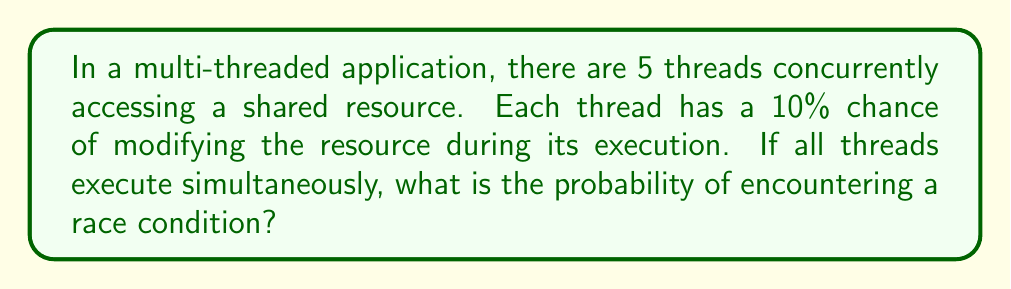Can you solve this math problem? Let's approach this step-by-step:

1) First, we need to understand what constitutes a race condition. A race condition occurs when two or more threads attempt to modify a shared resource simultaneously.

2) In this case, we're looking for the probability that at least two threads will attempt to modify the resource.

3) It's easier to calculate the probability of not having a race condition and then subtract that from 1.

4) The probability of a single thread not modifying the resource is 90% or 0.9.

5) For no race condition to occur, either no thread should modify the resource, or exactly one thread should modify it.

6) The probability of no thread modifying the resource is:

   $$P(\text{no modification}) = 0.9^5 = 0.59049$$

7) The probability of exactly one thread modifying the resource can be calculated using the binomial probability formula:

   $$P(\text{exactly one}) = \binom{5}{1} * 0.1 * 0.9^4 = 5 * 0.1 * 0.6561 = 0.32805$$

8) Therefore, the probability of not having a race condition is:

   $$P(\text{no race}) = 0.59049 + 0.32805 = 0.91854$$

9) The probability of having a race condition is the complement of this:

   $$P(\text{race}) = 1 - 0.91854 = 0.08146$$

10) Converting to a percentage: 0.08146 * 100 = 8.146%
Answer: 8.146% 